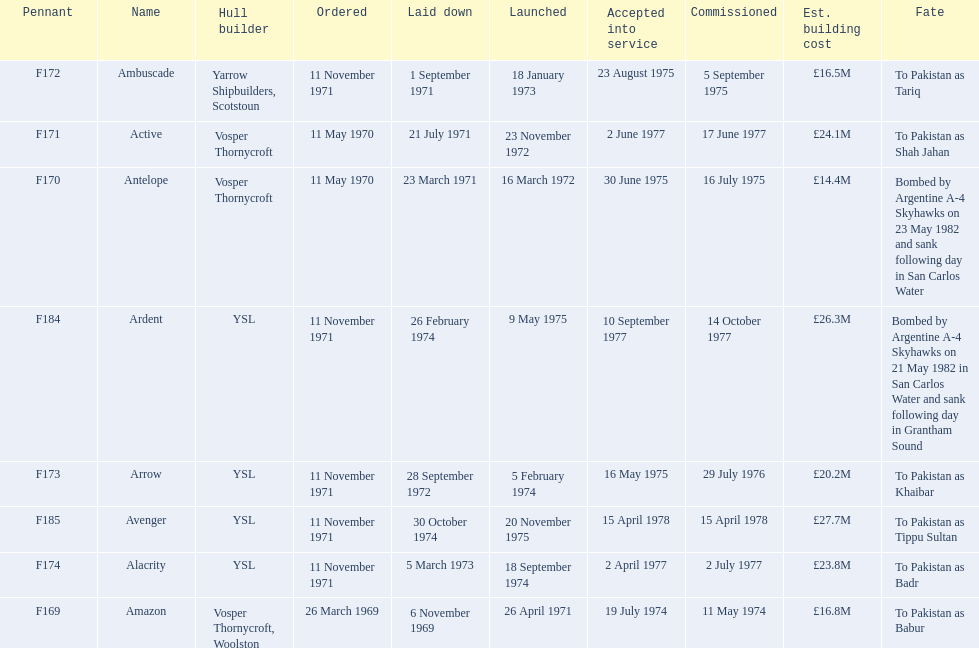Which ships cost more than ps25.0m to build? Ardent, Avenger. Of the ships listed in the answer above, which one cost the most to build? Avenger. 